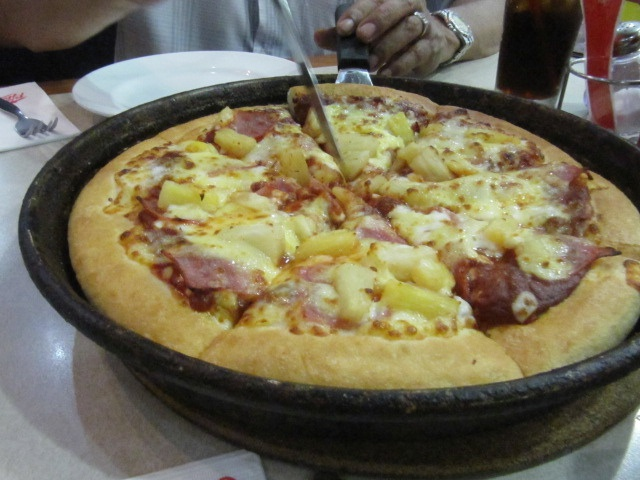Describe the objects in this image and their specific colors. I can see dining table in black, tan, darkgray, and gray tones, pizza in black, tan, khaki, gray, and olive tones, people in black, gray, and darkgray tones, cup in black, gray, and darkgray tones, and knife in black, gray, olive, and darkgray tones in this image. 